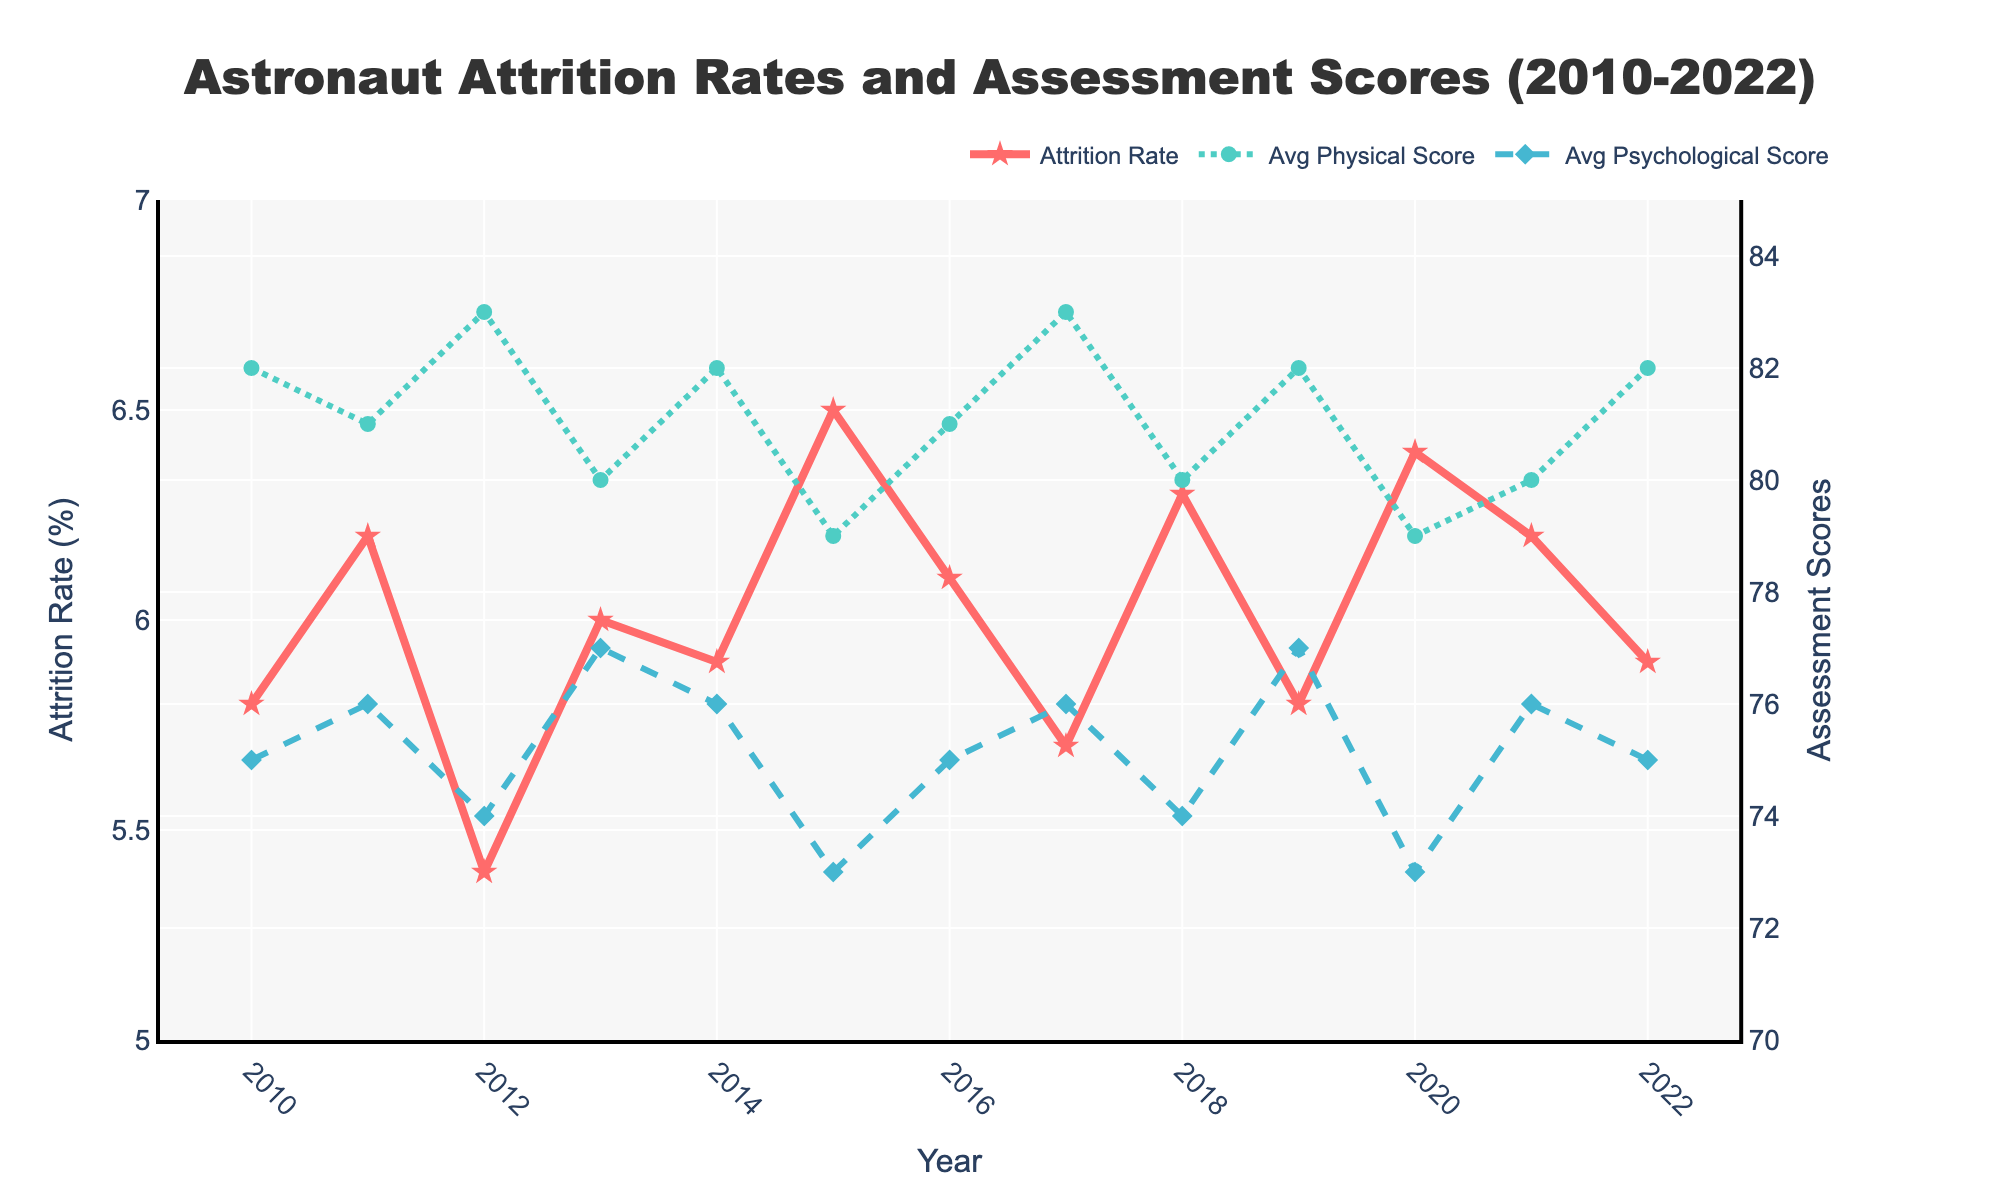What is the title of the figure? The title is located at the top of the figure, centered and in a larger font.
Answer: Astronaut Attrition Rates and Assessment Scores (2010-2022) How many years are represented in the figure? Count the data points on the x-axis or note the range of years from 2010 to 2022.
Answer: 13 What was the highest attrition rate recorded, and in which year did it occur? Identify the peak on the Attrition Rate line (red line) and find the corresponding year on the x-axis; for the highest value, look closely at the y-axis values.
Answer: 6.5% in 2015 What is the trend of the Average Physical Score from 2010 to 2022? Observe the green dotted line and see whether it generally rises, falls, or remains constant over the years.
Answer: Fluctuating slightly, no clear upward or downward trend In which year did the Average Psychological Score reach its lowest point? Find the minimum value on the blue dotted line and identify the corresponding year on the x-axis.
Answer: 2015 and 2020 How does the attrition rate in 2018 compare to the previous year? Compare the attrition rate of 2018 (6.3%) to 2017 (5.7%) by looking at the red line's points for those years.
Answer: Higher in 2018 What can you infer about the correlation between attrition rates and assessment scores? By visually analyzing whether the variations in attrition rates correspond with changes in assessment scores, deduce if there appears to be any notable relationship or pattern.
Answer: There seems to be no clear correlation; fluctuations in attrition rates do not consistently match changes in assessment scores What was the difference in the Average Physical Score between the years 2012 and 2013? Subtract the Average Physical Score in 2013 (80) from that in 2012 (83).
Answer: 3 Which year had the highest average psychological score, and what was the score? Find the peak on the blue dotted line and read the corresponding score and year from the x and y-axes.
Answer: 2013 with a score of 77 Was there any year where both the Average Physical Score and Average Psychological Score moved in the same direction compared to the previous year? Compare the direction of changes in both scores for consecutive years. If both increase or decrease in the same year, mark that year.
Answer: Yes, in 2020, both decreased 